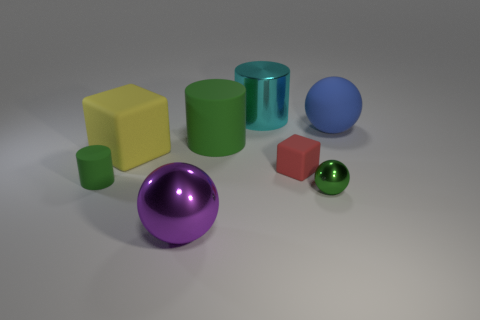Can you describe the lighting in this scene? The lighting in the scene appears to be soft and diffused, likely coming from a source above, as indicated by the gentle shadows underneath each object. There's no harsh direct light, which gives the image a calm and even tone. Does the lighting have any effect on the colors of the objects? Yes, the diffuse lighting helps to bring out the true colors of the objects without creating overly bright highlights or deep shadows, allowing each object's hue to be distinctly visible and easily identifiable. 